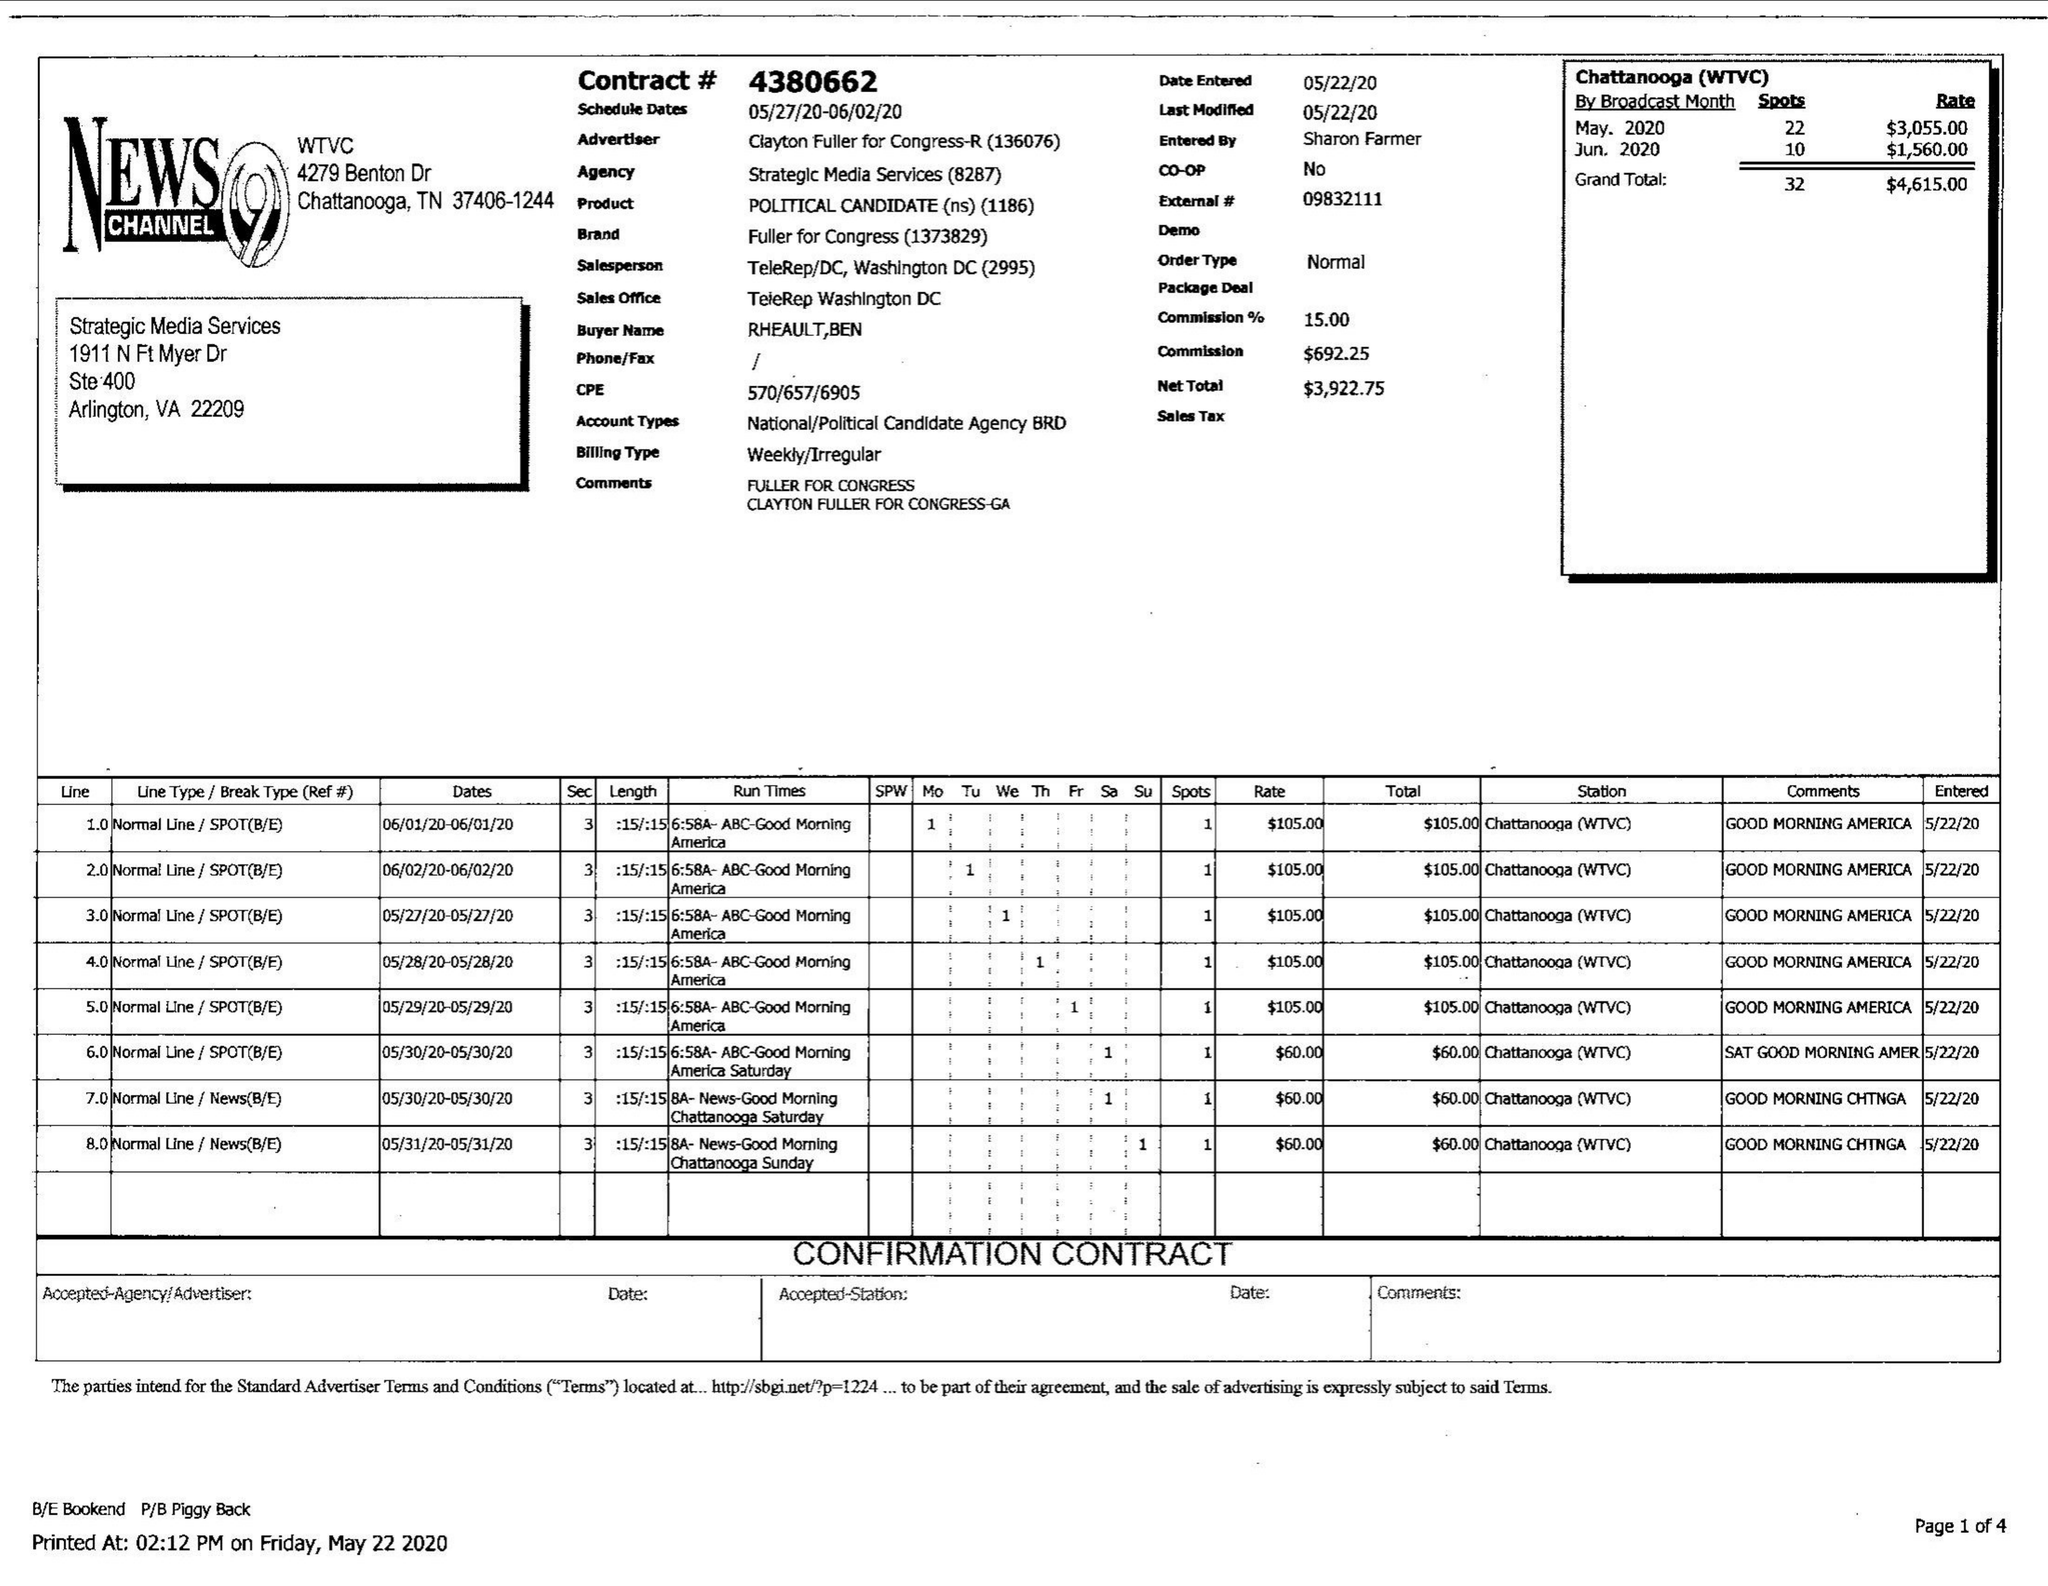What is the value for the flight_to?
Answer the question using a single word or phrase. 06/02/20 